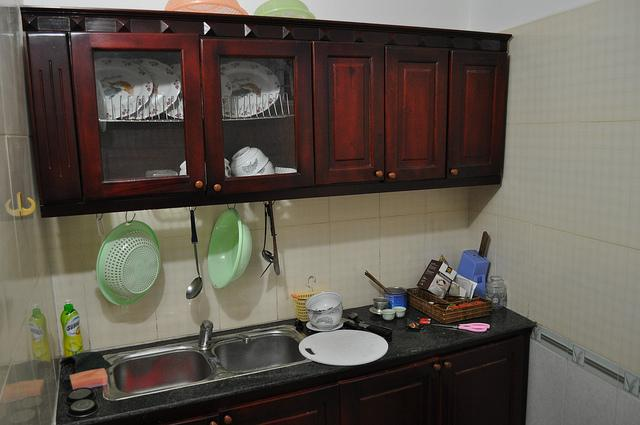What is the pink item on the counter?

Choices:
A) scissor handle
B) spoon
C) napkin
D) fork scissor handle 